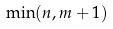Convert formula to latex. <formula><loc_0><loc_0><loc_500><loc_500>\min ( n , m + 1 )</formula> 